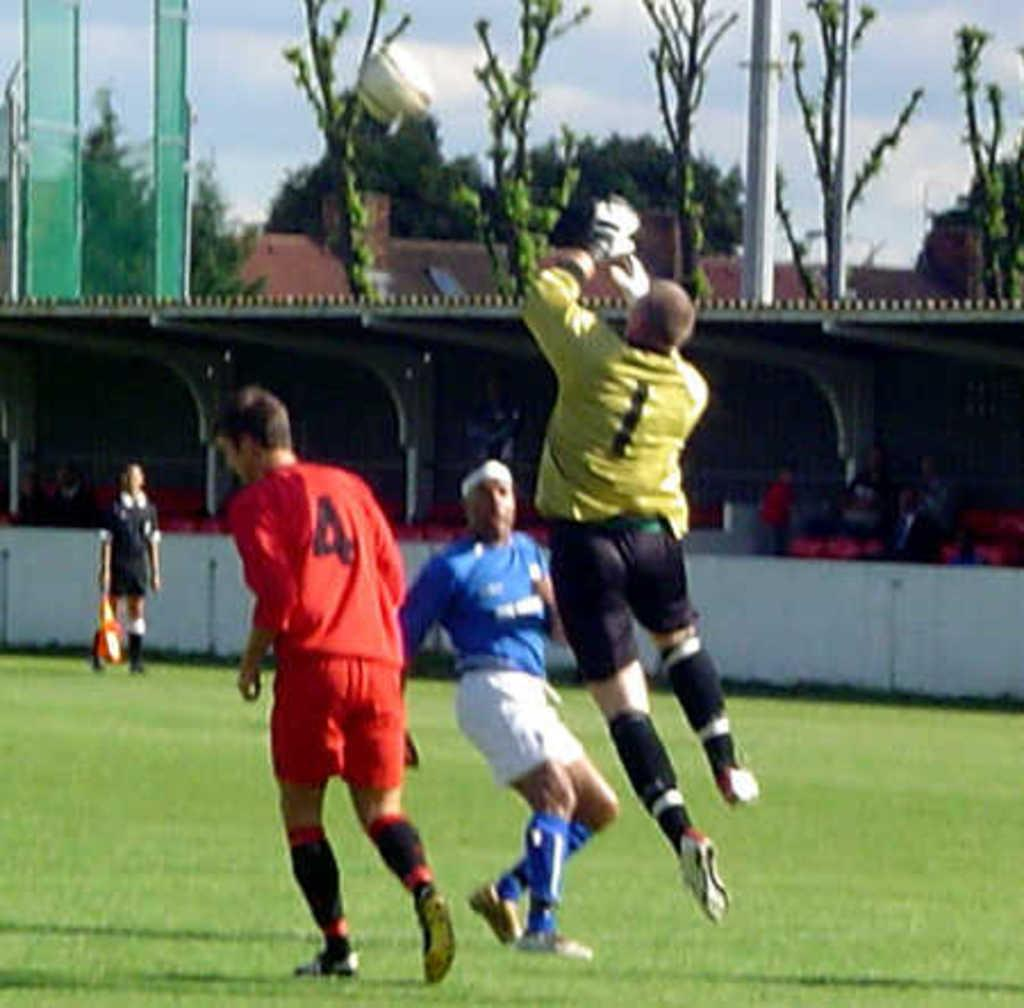<image>
Share a concise interpretation of the image provided. Player number 1 is jumping up into the air with his hands out to catch a soccer ball. 